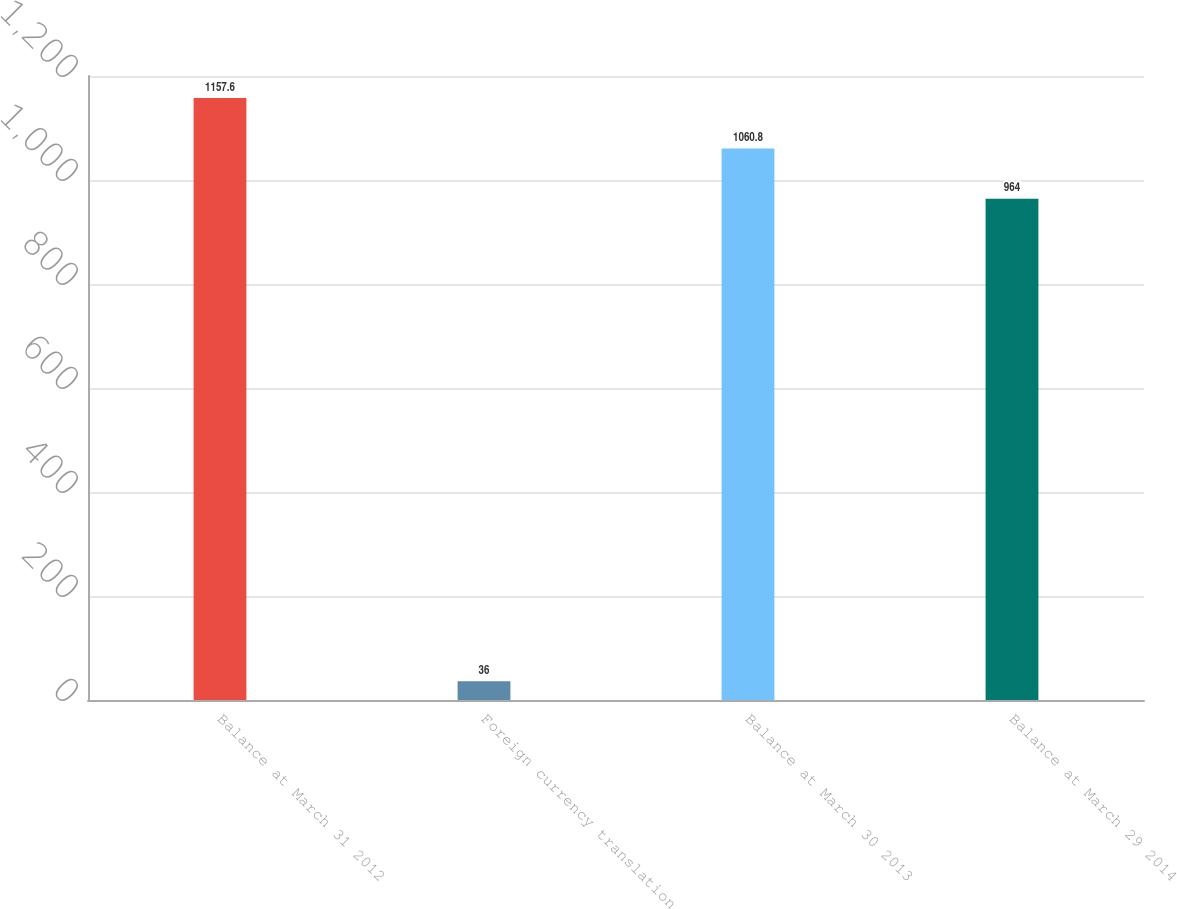<chart> <loc_0><loc_0><loc_500><loc_500><bar_chart><fcel>Balance at March 31 2012<fcel>Foreign currency translation<fcel>Balance at March 30 2013<fcel>Balance at March 29 2014<nl><fcel>1157.6<fcel>36<fcel>1060.8<fcel>964<nl></chart> 